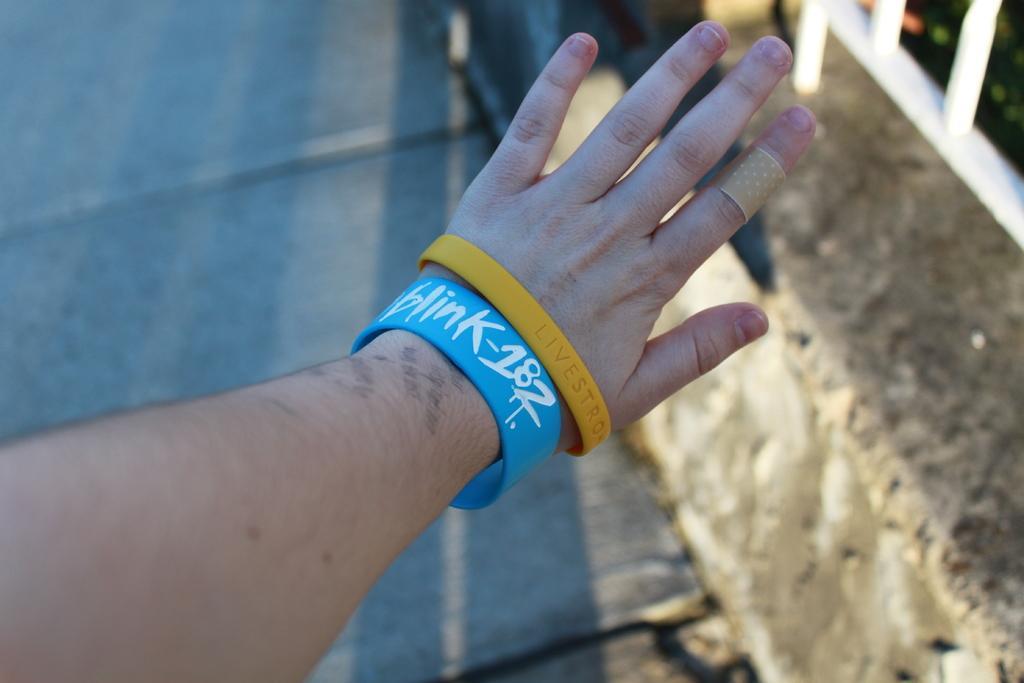Describe this image in one or two sentences. In this image in the front there is a hand of the person with some bands and there is some text written on the bands. On the right side there is a railing which is white in colour. In the center there is a floor. 